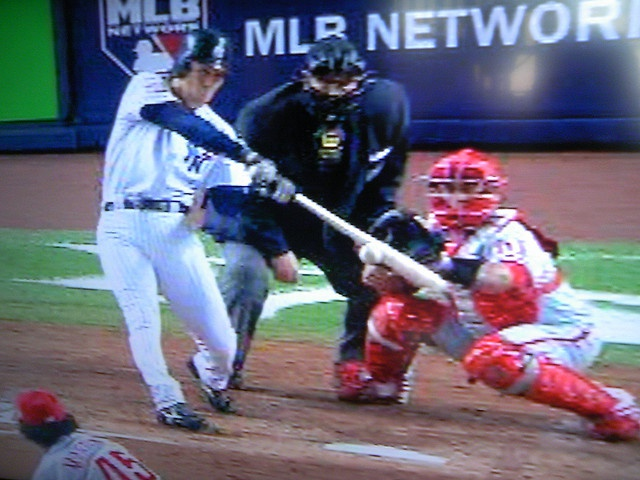Describe the objects in this image and their specific colors. I can see people in darkgreen, lightblue, and navy tones, people in darkgreen, lavender, maroon, brown, and violet tones, people in darkgreen, black, navy, gray, and blue tones, people in darkgreen, gray, black, and maroon tones, and baseball bat in darkgreen, white, darkgray, and black tones in this image. 